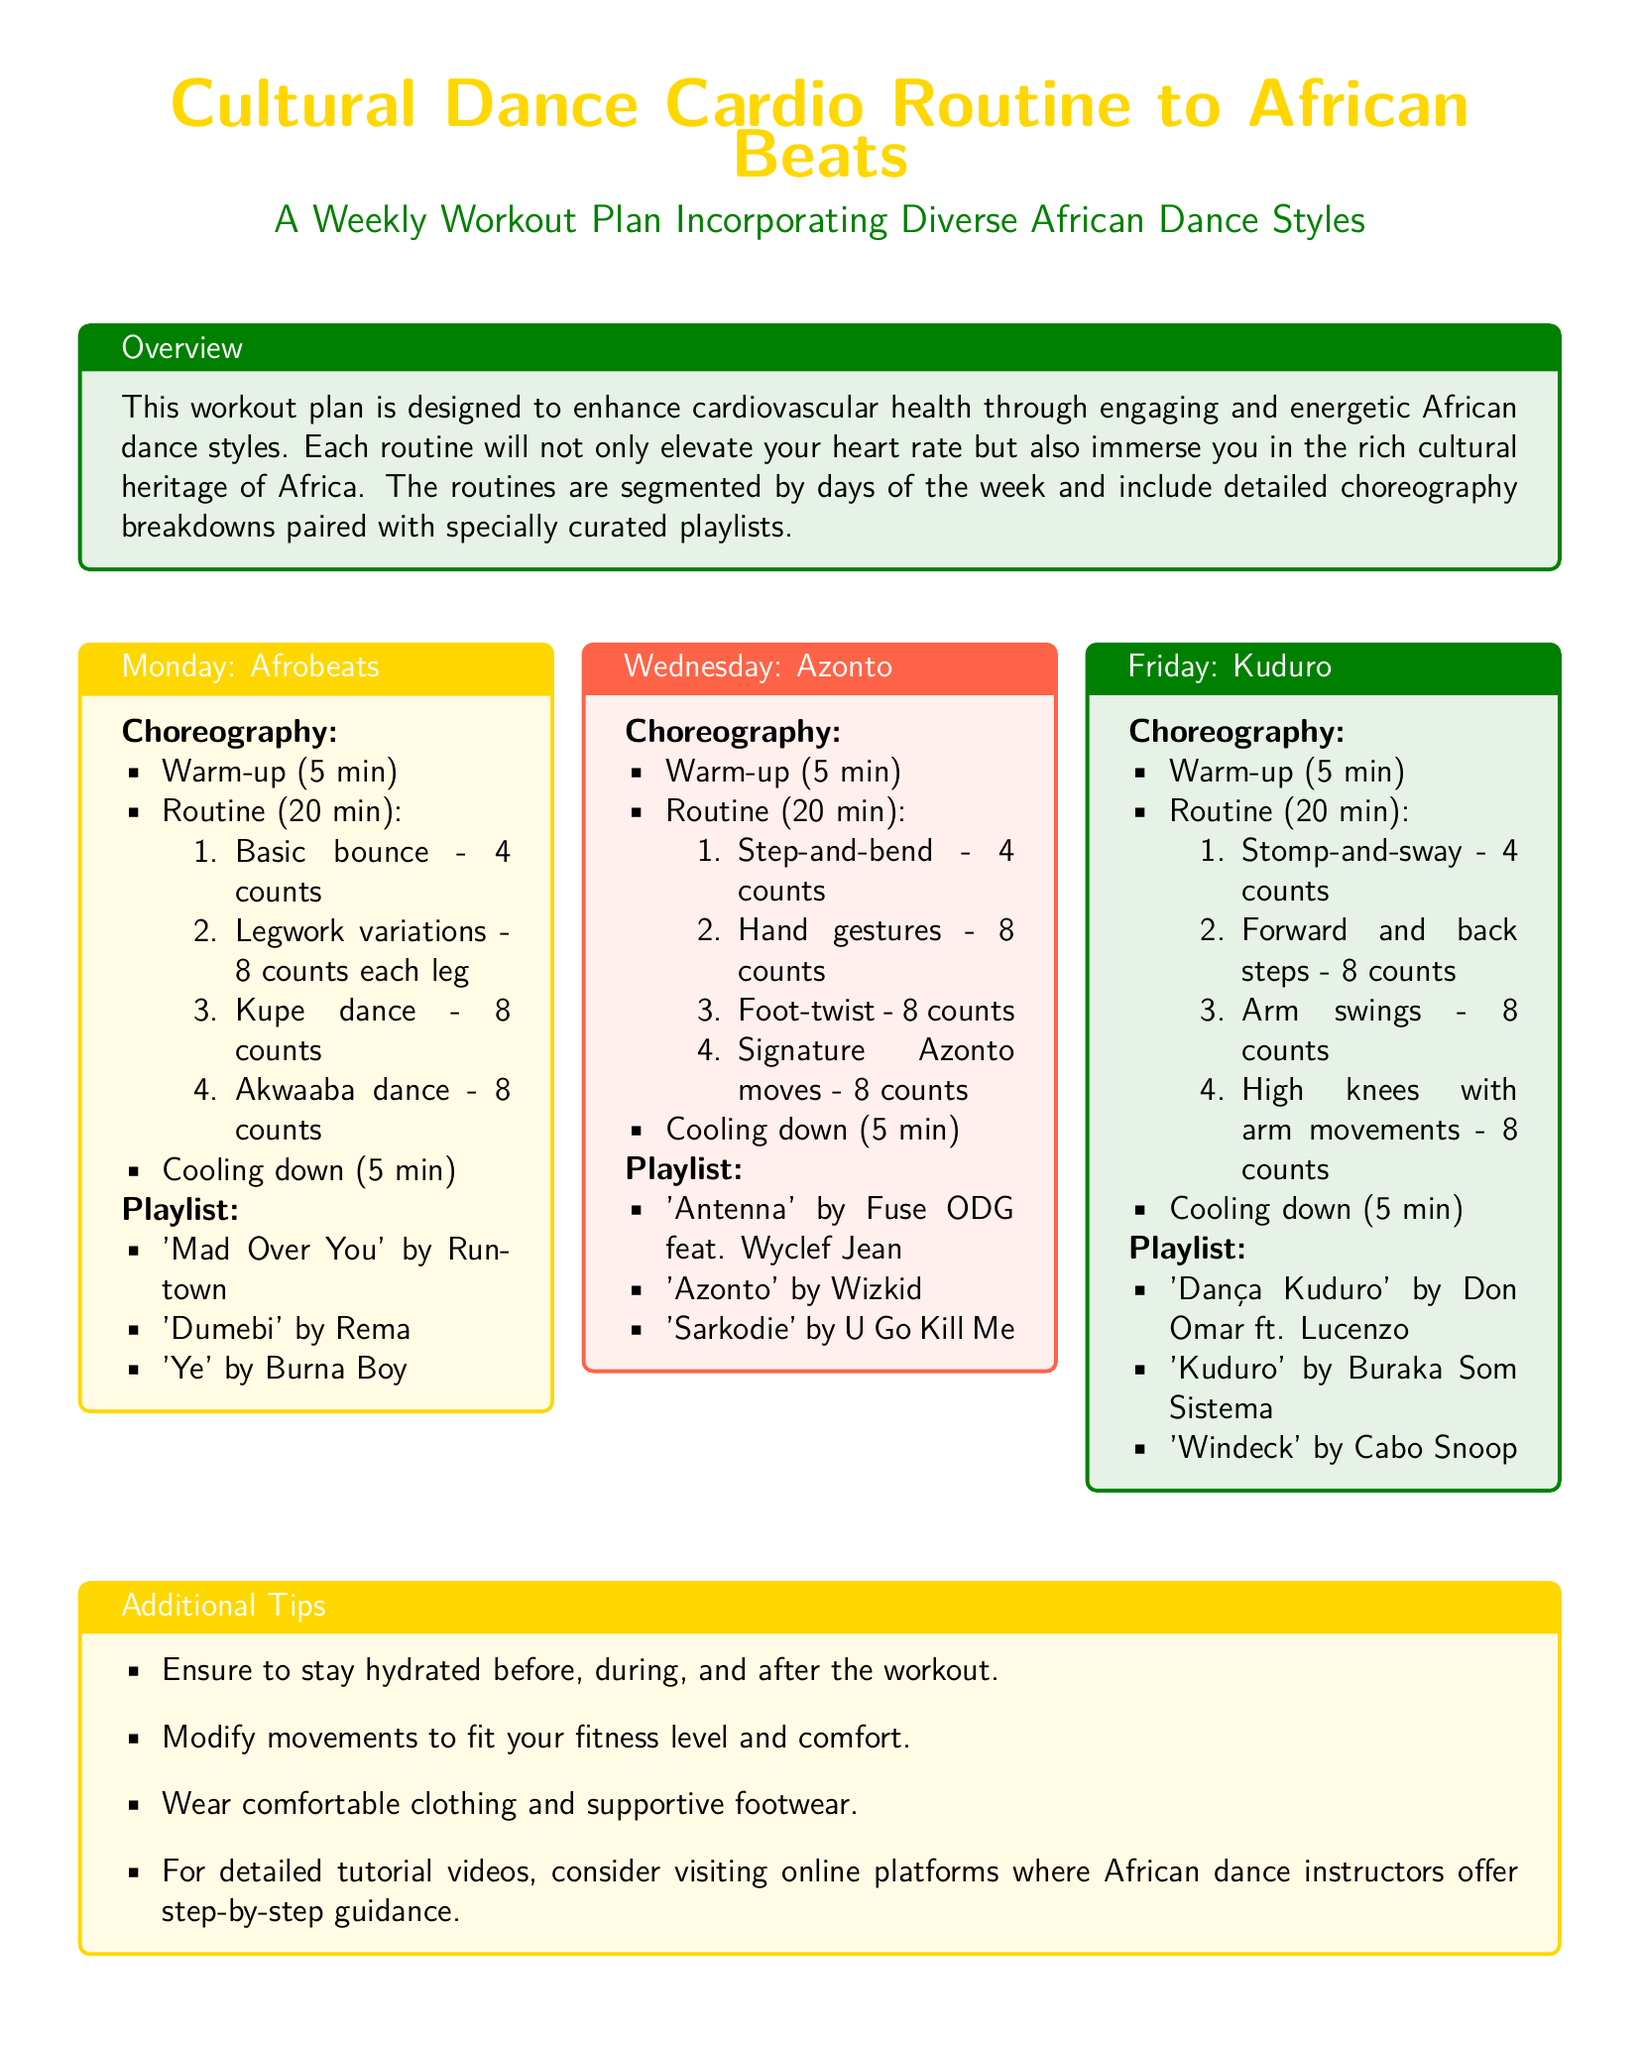What is the title of the document? The title of the document is highlighted in the center at the beginning of the document.
Answer: Cultural Dance Cardio Routine to African Beats How many minutes is the warm-up for Monday's routine? The warm-up duration is specified in the choreography section for Monday.
Answer: 5 min What dance style is featured on Wednesday? The dance style for Wednesday is mentioned in the title of the Wednesday workout box.
Answer: Azonto How many songs are listed in the Friday playlist? The number of songs is determined by counting the items in the Friday playlist.
Answer: 3 What is the main goal of the workout plan? The main goal is described in the overview section of the document.
Answer: Enhance cardiovascular health What type of clothing is suggested for the workouts? The suggestion for clothing is provided in the additional tips section.
Answer: Comfortable clothing What is the total time for the routine on Monday? Total time is calculated by adding the warm-up, routine, and cooling down durations.
Answer: 30 min What does the workout plan incorporate? The main feature of the workout plan is detailed in the overview section.
Answer: Diverse African dance styles What is recommended for hydration? This recommendation can be found in the additional tips section under hydration advice.
Answer: Stay hydrated 